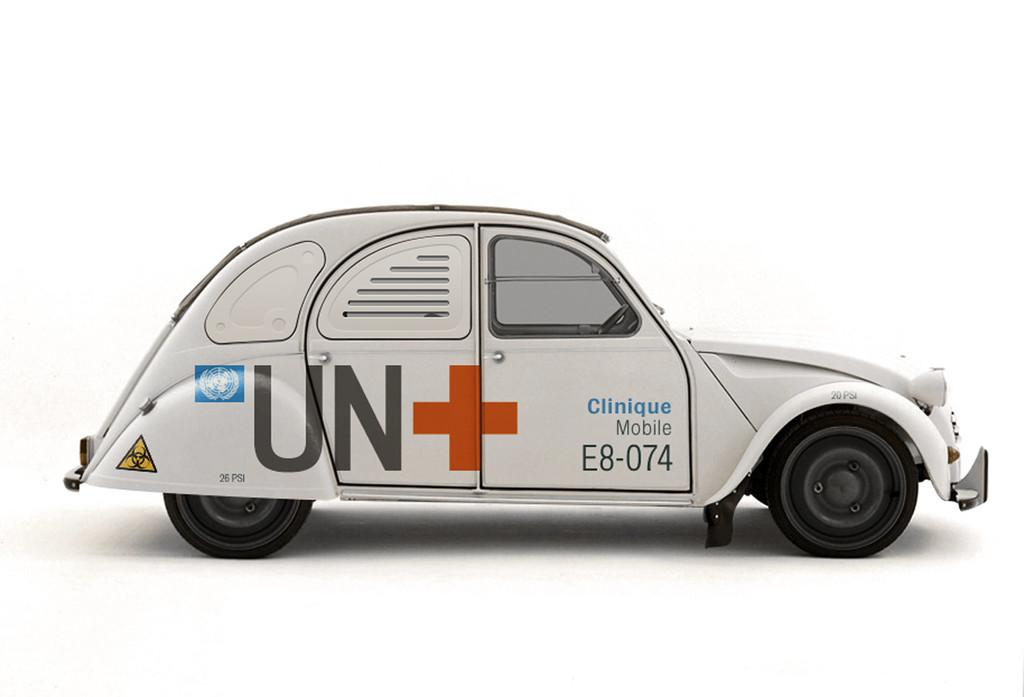What is the main subject of the image? The main subject of the image is a vehicle. What specific features can be seen on the vehicle? The vehicle has symbols and text on it. Can you tell me how many plantations are visible in the image? There are no plantations present in the image; it features a vehicle with symbols and text. What type of vein is depicted on the vehicle in the image? There is no vein depicted on the vehicle in the image; it only has symbols and text. 